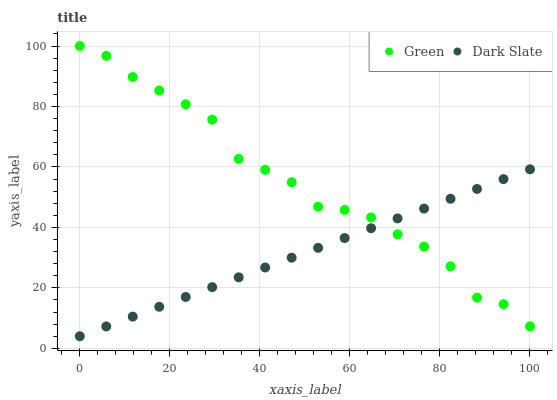Does Dark Slate have the minimum area under the curve?
Answer yes or no. Yes. Does Green have the maximum area under the curve?
Answer yes or no. Yes. Does Green have the minimum area under the curve?
Answer yes or no. No. Is Dark Slate the smoothest?
Answer yes or no. Yes. Is Green the roughest?
Answer yes or no. Yes. Is Green the smoothest?
Answer yes or no. No. Does Dark Slate have the lowest value?
Answer yes or no. Yes. Does Green have the lowest value?
Answer yes or no. No. Does Green have the highest value?
Answer yes or no. Yes. Does Green intersect Dark Slate?
Answer yes or no. Yes. Is Green less than Dark Slate?
Answer yes or no. No. Is Green greater than Dark Slate?
Answer yes or no. No. 